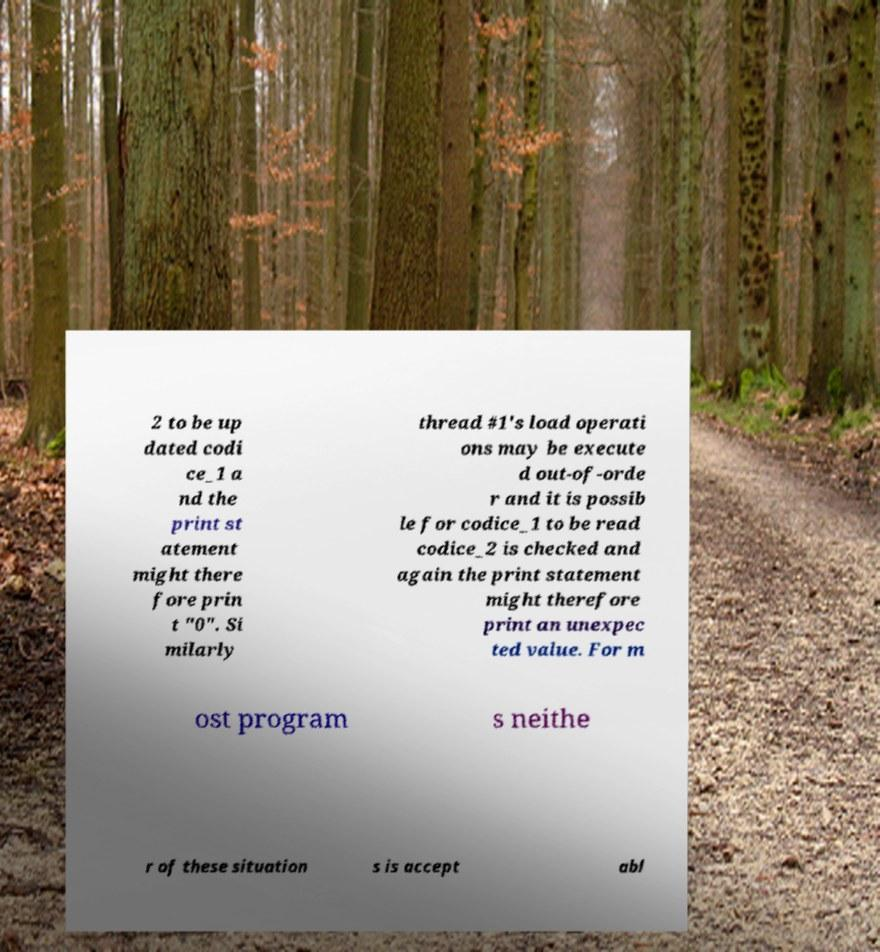For documentation purposes, I need the text within this image transcribed. Could you provide that? 2 to be up dated codi ce_1 a nd the print st atement might there fore prin t "0". Si milarly thread #1's load operati ons may be execute d out-of-orde r and it is possib le for codice_1 to be read codice_2 is checked and again the print statement might therefore print an unexpec ted value. For m ost program s neithe r of these situation s is accept abl 